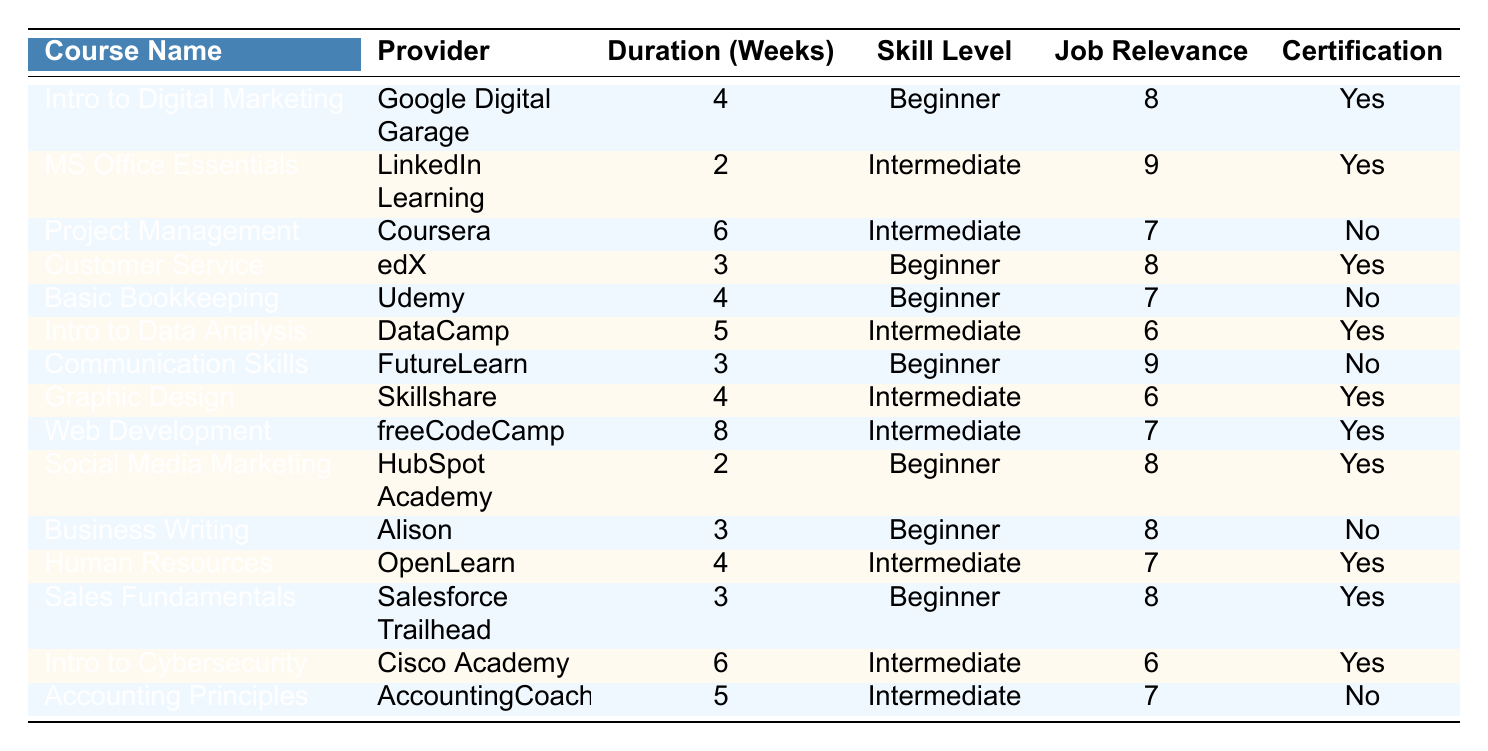What is the duration of the "Introduction to Data Analysis" course? The table lists the duration of each course. For "Introduction to Data Analysis" under "Duration (Weeks)," it shows 5 weeks.
Answer: 5 weeks Which course has the highest job relevance score? The job relevance scores are 8, 9, or 7 across different courses. The highest score listed is 9, which belongs to "Microsoft Office Essentials" and "Effective Communication Skills."
Answer: Microsoft Office Essentials and Effective Communication Skills How many courses offer certification? By checking the "Certification" column, there are a total of 8 courses marked with "Yes."
Answer: 8 What is the average duration of the courses that provide certifications? Identify the durations of the courses that offer certification, which are 4, 2, 3, 4, 3, 6, 4, and 6 weeks. The sum is 32 weeks, and there are 8 courses, so the average is 32/8 = 4 weeks.
Answer: 4 weeks Are there any courses that are suitable for beginners with a job relevance score of 8 or more? Review the courses suitable for beginners (Skill Level 1) with a job relevance score of 8 or higher. The relevant courses are "Introduction to Digital Marketing," "Customer Service Fundamentals," and "Social Media Marketing."
Answer: Yes Which course has the longest duration among those with a job relevance score of 7 or less? List the courses with job relevance scores of 7 or less: "Fundamentals of Project Management" (6 weeks), "Basic Bookkeeping" (4 weeks), "Introduction to Data Analysis" (5 weeks), "Graphic Design" (4 weeks), "Accounting Principles" (5 weeks). The longest is "Fundamentals of Project Management" with 6 weeks.
Answer: Fundamentals of Project Management How many courses are offered by Coursera? The table lists the providers for each course. Only one course, "Fundamentals of Project Management," is provided by Coursera.
Answer: 1 Is there a course on Cybersecurity, and does it offer a certificate? Looking at the table, "Introduction to Cybersecurity" is listed under courses, and it has "Yes" mentioned for certification.
Answer: Yes What is the total number of courses categorized as Intermediate skill level? Check the "Skill Level" column for entries marked as Intermediate (Level 2). The relevant courses are "Microsoft Office Essentials," "Fundamentals of Project Management," "Introduction to Data Analysis," "Graphic Design," "Web Development," "Human Resources," "Introduction to Cybersecurity," and "Accounting Principles," which totals 7 courses.
Answer: 7 Which course is the shortest in terms of duration? By examining the "Duration (Weeks)" column, the shortest duration is 2 weeks for both "Microsoft Office Essentials" and "Social Media Marketing."
Answer: Microsoft Office Essentials and Social Media Marketing 